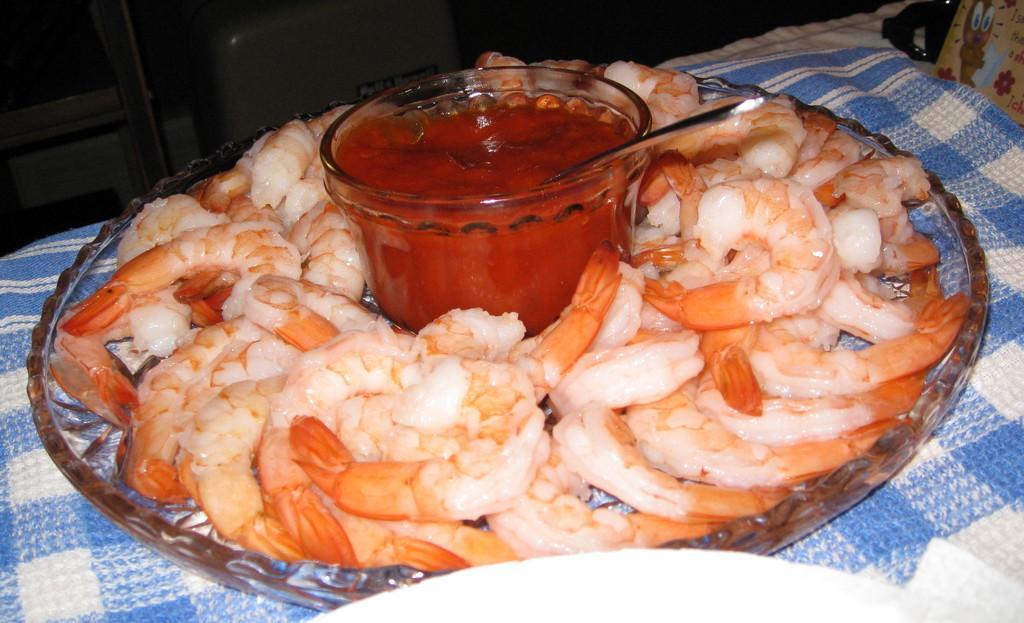How would you summarize this image in a sentence or two? In this image we can see some prawns and a bowl with sauce and a spoon in a plate which is placed on a cloth. 